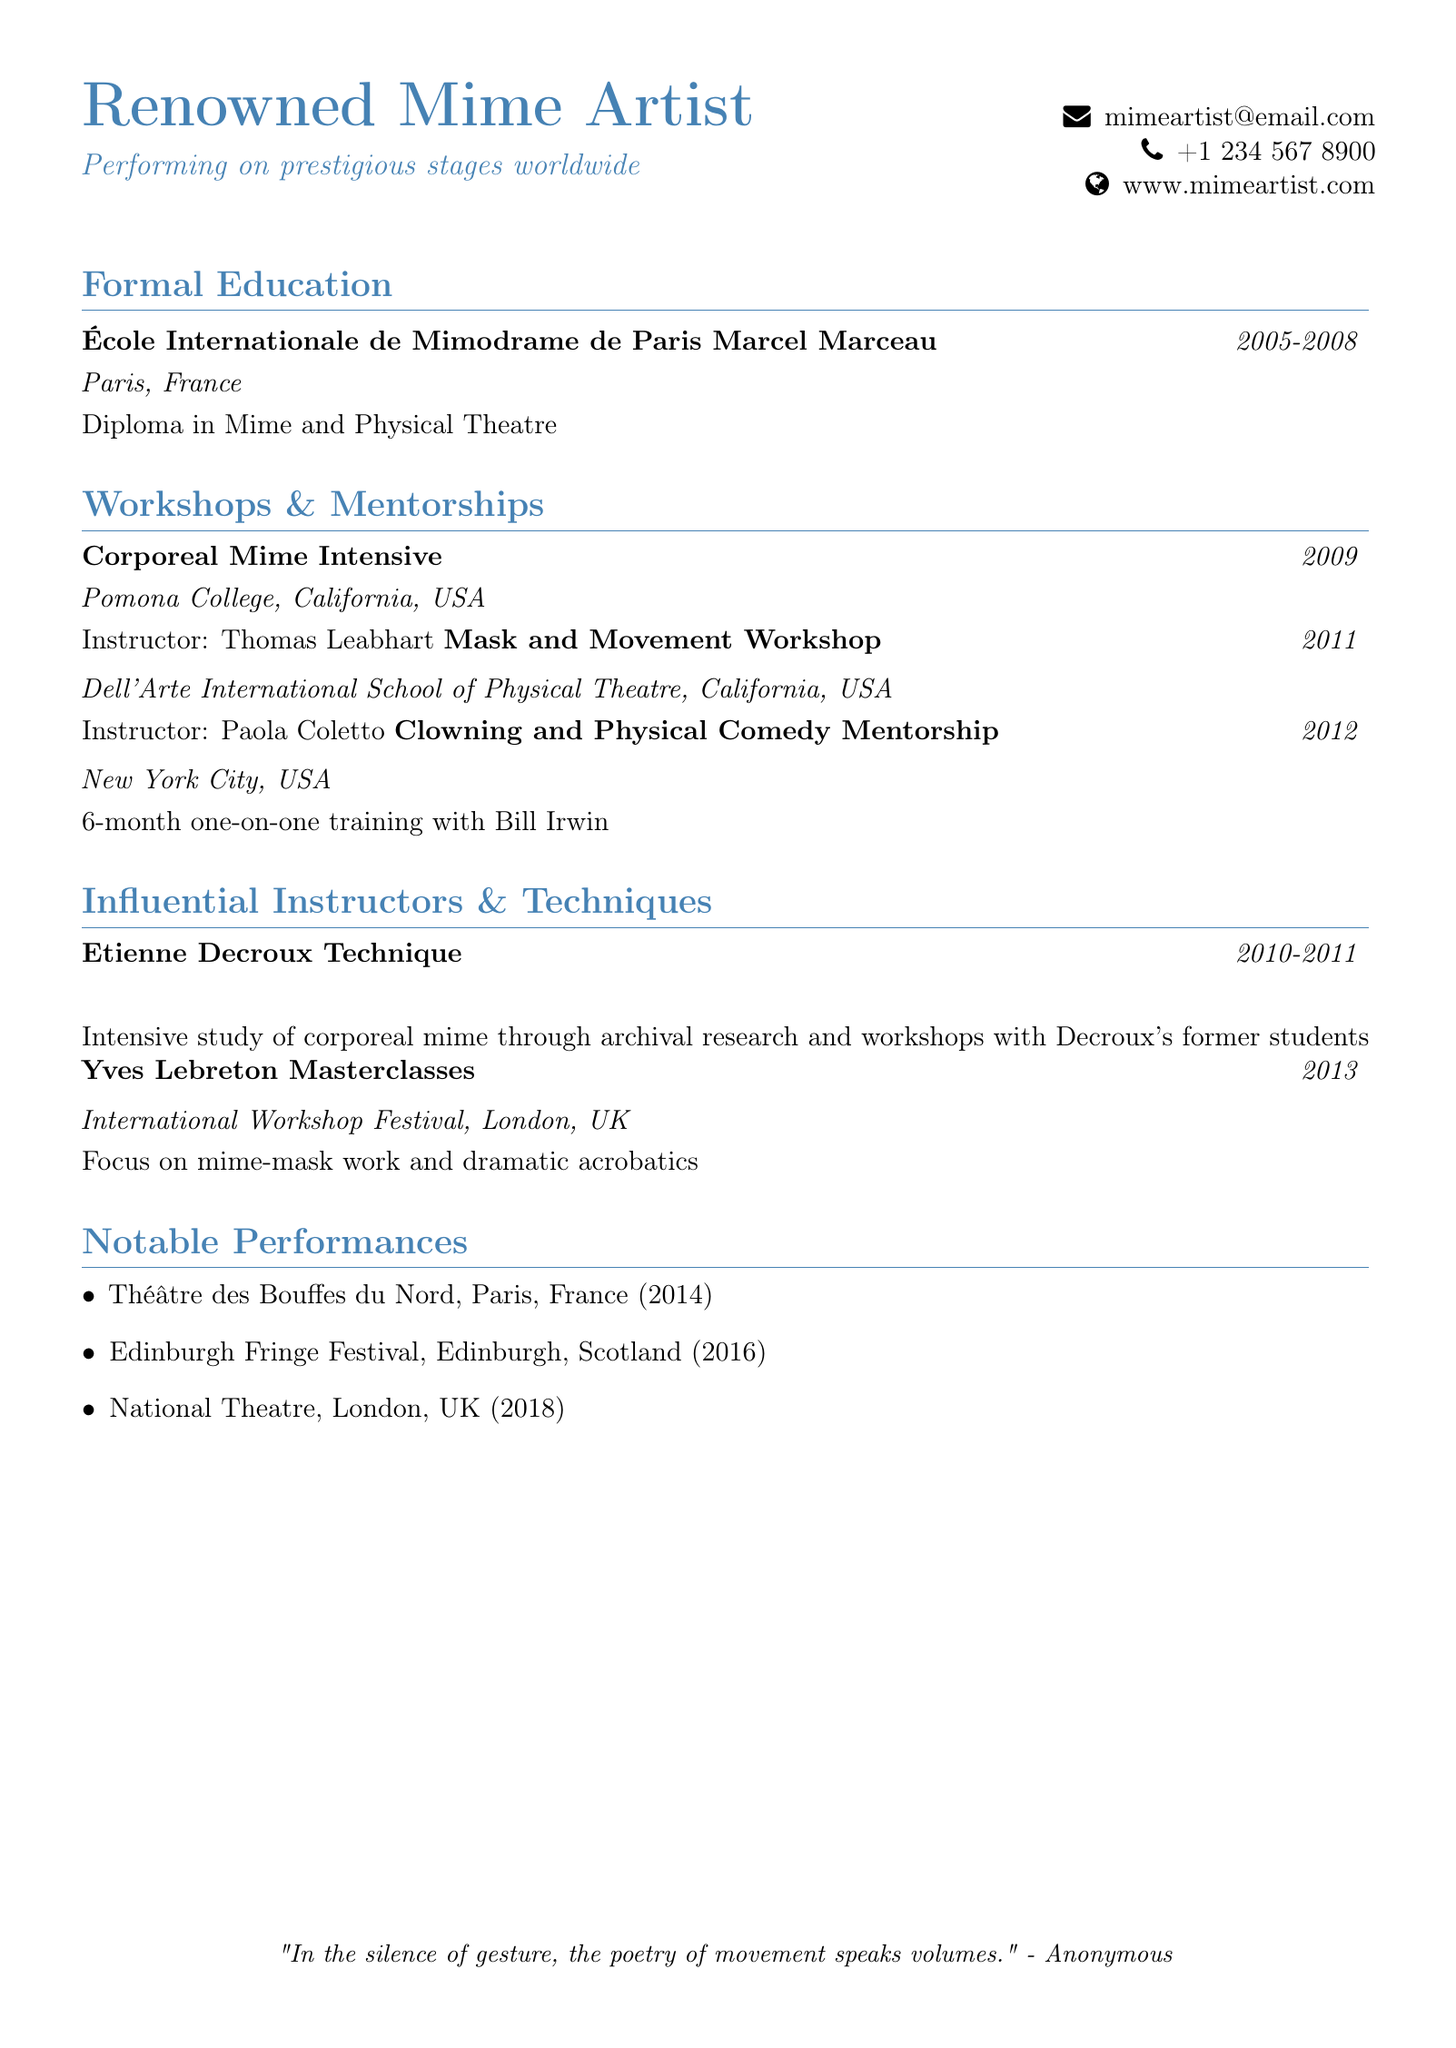What institution did the mime artist graduate from? The institutional name is mentioned under formal education as École Internationale de Mimodrame de Paris Marcel Marceau.
Answer: École Internationale de Mimodrame de Paris Marcel Marceau What degree did the mime artist earn? The degree acquired at the institution is stated in the formal education section as a Diploma in Mime and Physical Theatre.
Answer: Diploma in Mime and Physical Theatre In what year did the mime artist participate in the Corporeal Mime Intensive workshop? The year for the workshop can be found within the workshops section of the document, specified as 2009.
Answer: 2009 Who was the mentor for the one-on-one training in clowning and physical comedy? The mentor's name is explicitly mentioned in the mentorship section as Bill Irwin.
Answer: Bill Irwin What city hosted the Mask and Movement Workshop? The city for the said workshop is noted in the corresponding workshop entry as California, USA.
Answer: California, USA What technique did the mime artist study under Etienne Decroux? The document notes that the study was focused on the corporeal mime technique.
Answer: corporeal mime technique Which festival did the mime artist perform at in 2016? The performance year is provided in the notable performances section, specifically naming the Edinburgh Fringe Festival.
Answer: Edinburgh Fringe Festival What was the location of the mentorship with Bill Irwin? The location for the mentorship is mentioned as New York City, USA.
Answer: New York City, USA During what years did the mime artist study under Etienne Decroux? The years of study are specified in the influential instructors section, indicated as 2010-2011.
Answer: 2010-2011 